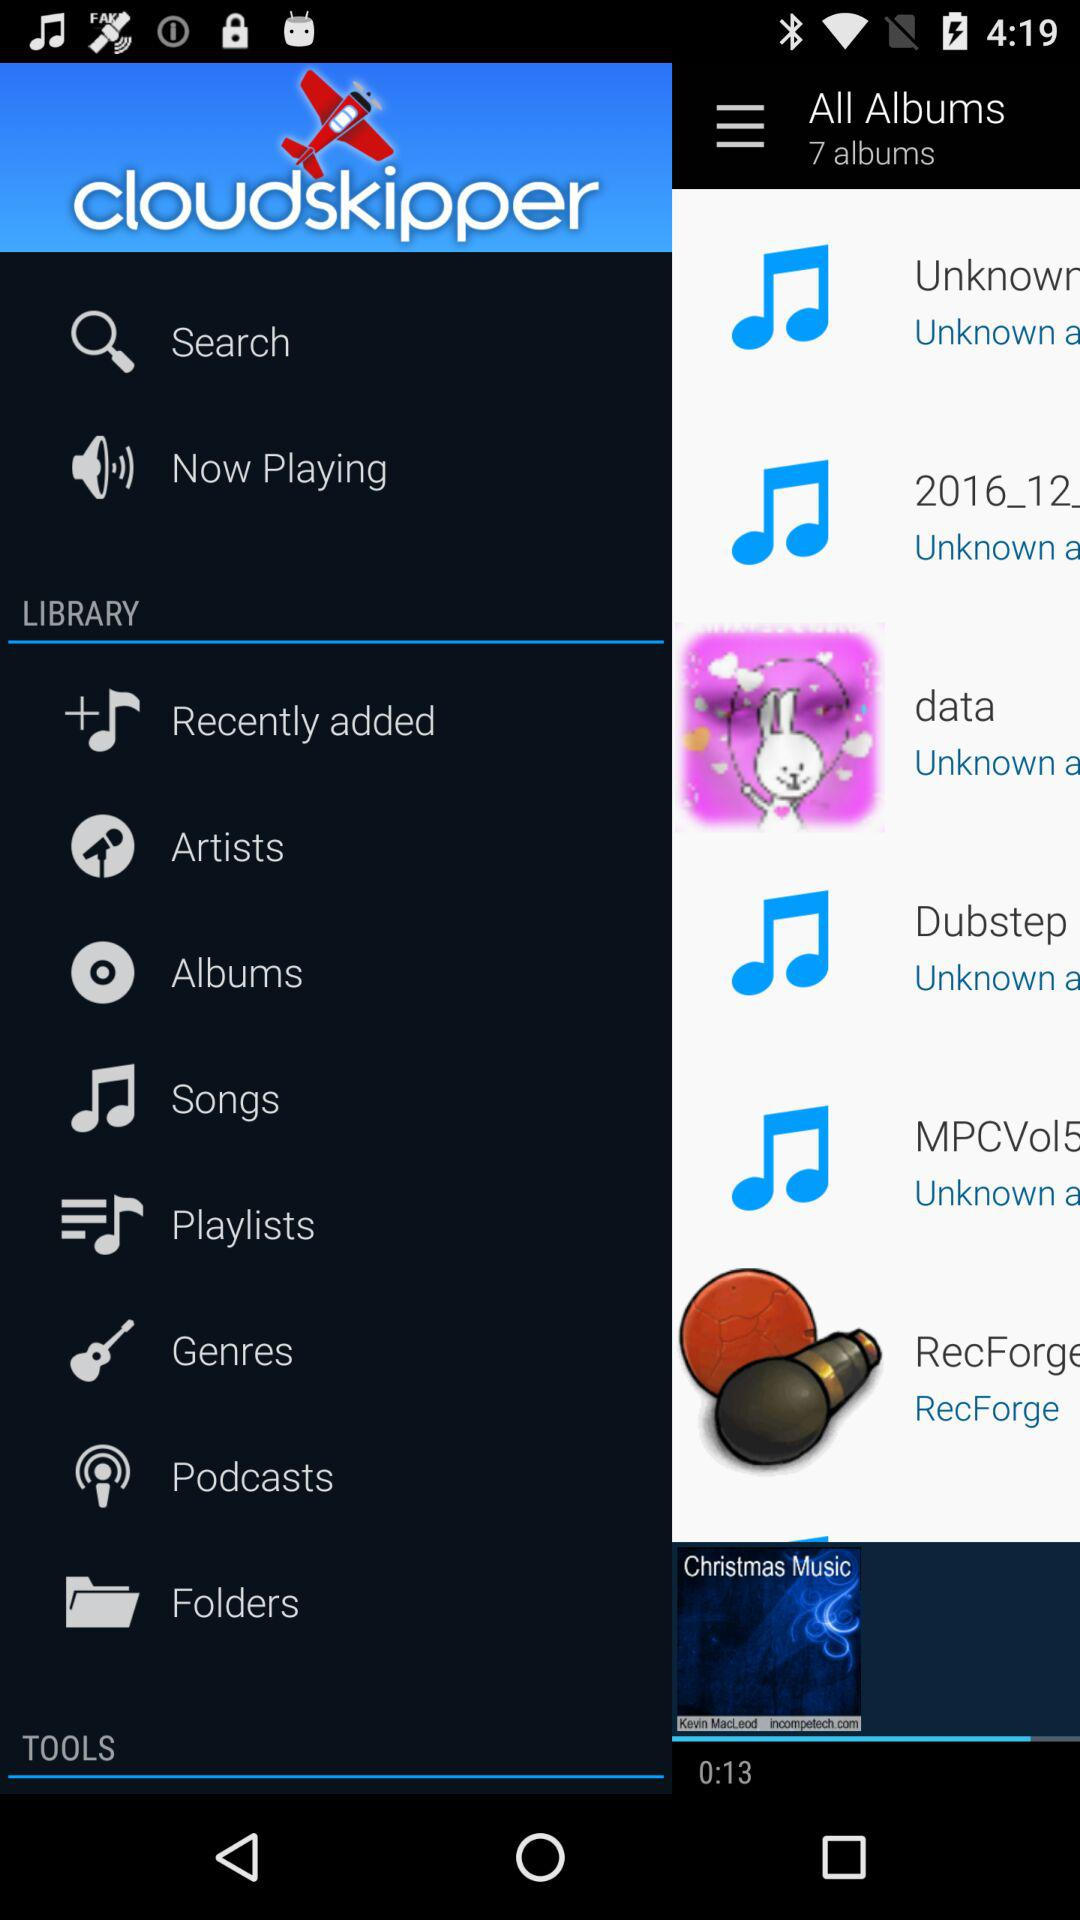What is the application name? The application name is "cloudskipper". 